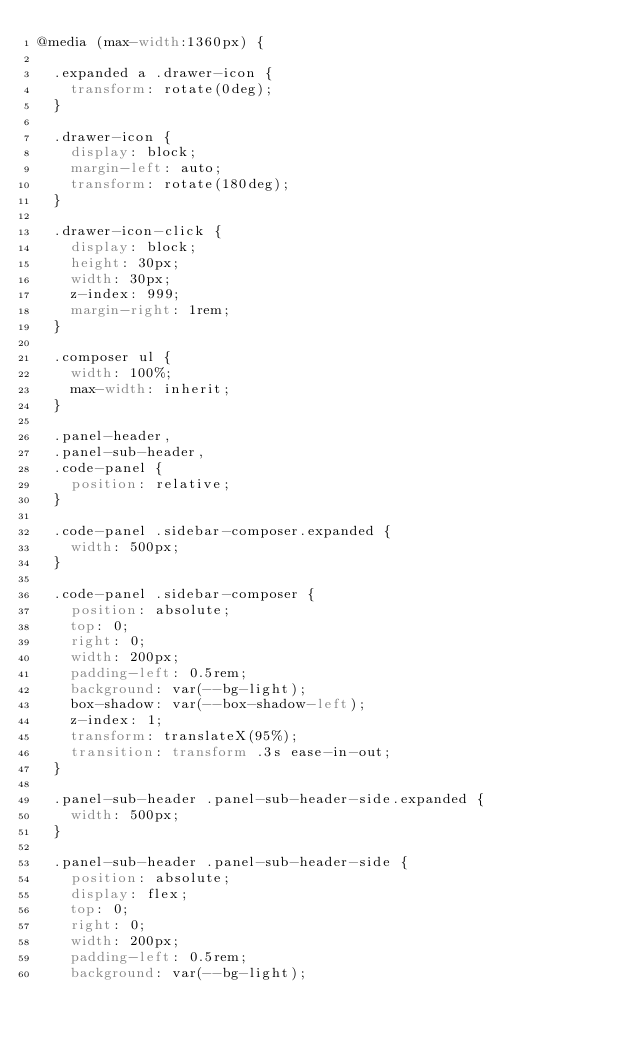Convert code to text. <code><loc_0><loc_0><loc_500><loc_500><_CSS_>@media (max-width:1360px) {

  .expanded a .drawer-icon {
    transform: rotate(0deg);
  }
  
  .drawer-icon {
    display: block;
    margin-left: auto;
    transform: rotate(180deg);
  }

  .drawer-icon-click {
    display: block;
    height: 30px;
    width: 30px;
    z-index: 999;
    margin-right: 1rem;
  }

  .composer ul {
    width: 100%;
    max-width: inherit;
  }

  .panel-header,
  .panel-sub-header,
  .code-panel {
    position: relative;
  }

  .code-panel .sidebar-composer.expanded {
    width: 500px;
  }

  .code-panel .sidebar-composer {
    position: absolute;
    top: 0;
    right: 0;
    width: 200px;
    padding-left: 0.5rem;
    background: var(--bg-light);
    box-shadow: var(--box-shadow-left);
    z-index: 1;
    transform: translateX(95%);
    transition: transform .3s ease-in-out;
  }

  .panel-sub-header .panel-sub-header-side.expanded {
    width: 500px;
  }

  .panel-sub-header .panel-sub-header-side {
    position: absolute;
    display: flex;
    top: 0;
    right: 0;
    width: 200px;
    padding-left: 0.5rem;
    background: var(--bg-light);</code> 